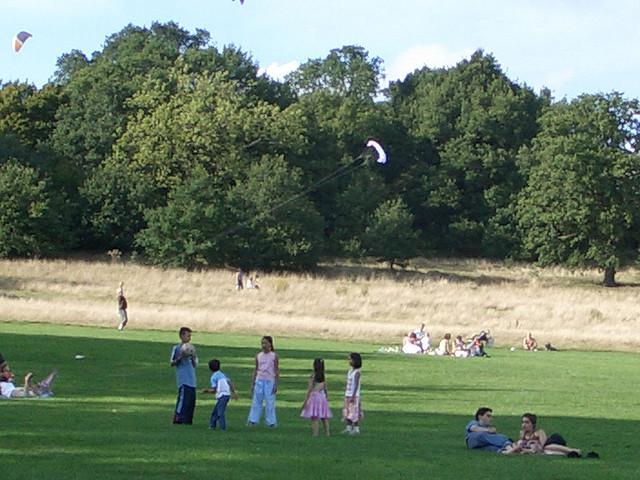Are there any people?
Keep it brief. Yes. Is there a red truck in the background?
Short answer required. No. What is the little boy dragging along?
Short answer required. Kite. What game are they playing?
Write a very short answer. Kite flying. Is anyone laying on the lawn?
Answer briefly. Yes. What is in the background?
Quick response, please. Trees. Are all these people doing the same activity?
Concise answer only. No. How many groups of people are in the sun?
Give a very brief answer. 4. 